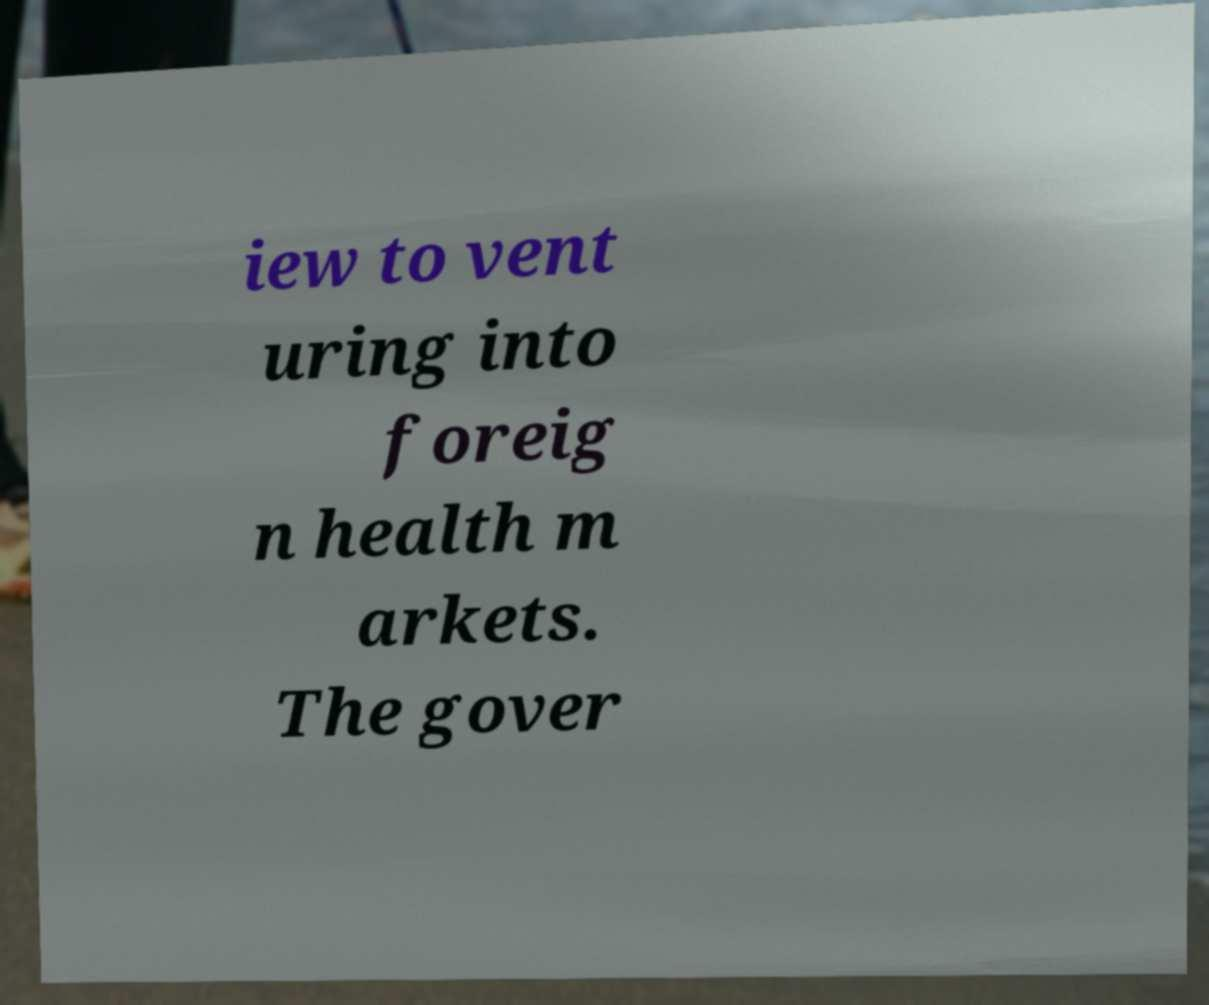Could you extract and type out the text from this image? iew to vent uring into foreig n health m arkets. The gover 